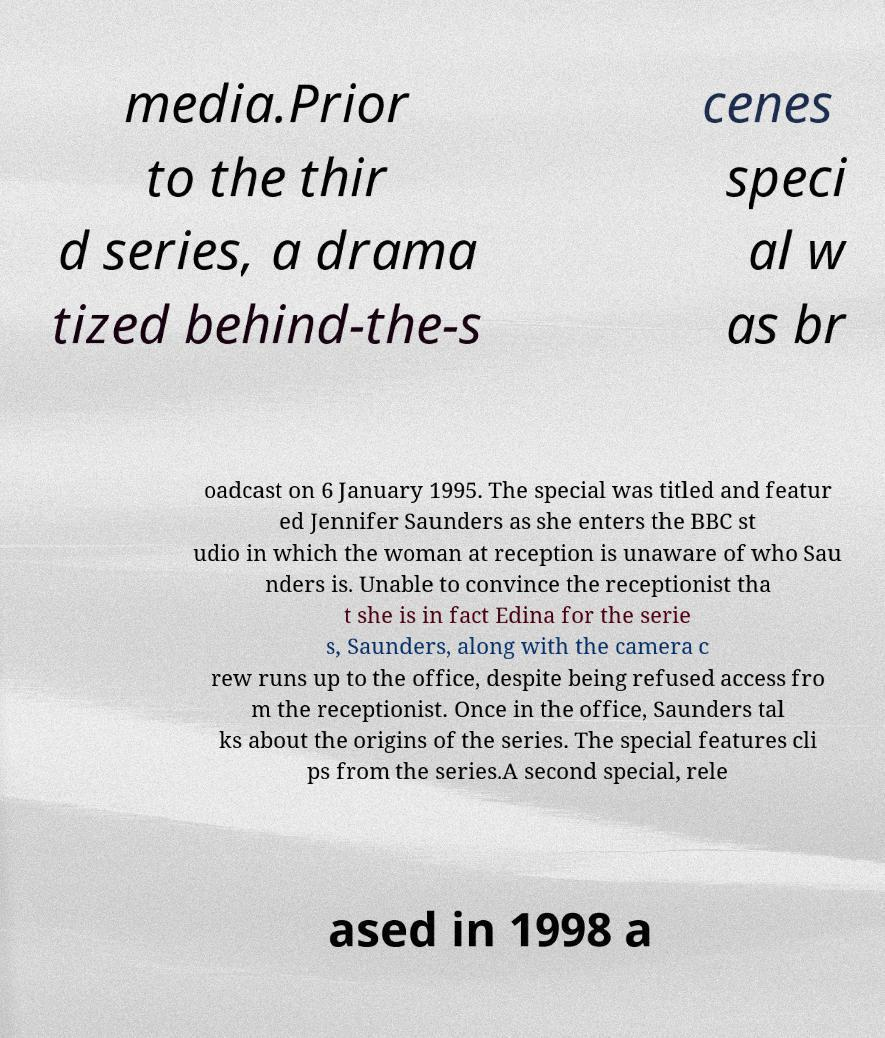Please read and relay the text visible in this image. What does it say? media.Prior to the thir d series, a drama tized behind-the-s cenes speci al w as br oadcast on 6 January 1995. The special was titled and featur ed Jennifer Saunders as she enters the BBC st udio in which the woman at reception is unaware of who Sau nders is. Unable to convince the receptionist tha t she is in fact Edina for the serie s, Saunders, along with the camera c rew runs up to the office, despite being refused access fro m the receptionist. Once in the office, Saunders tal ks about the origins of the series. The special features cli ps from the series.A second special, rele ased in 1998 a 